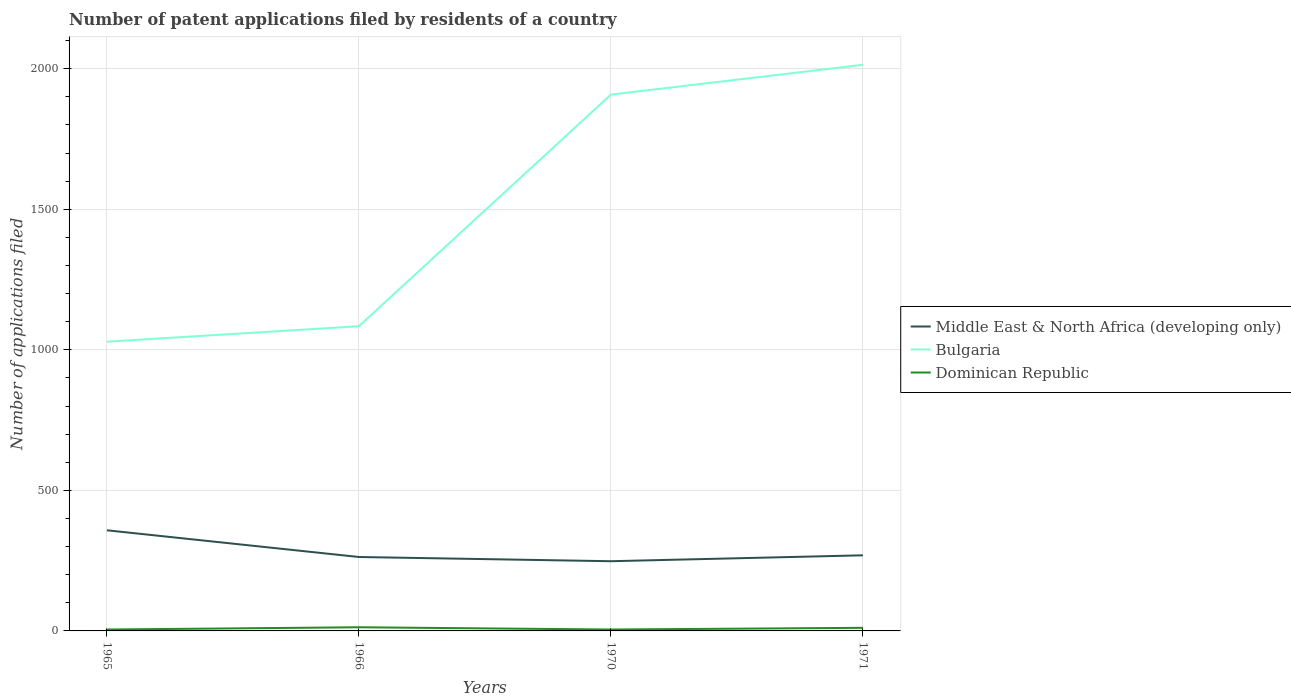Across all years, what is the maximum number of applications filed in Middle East & North Africa (developing only)?
Your answer should be very brief. 248. In which year was the number of applications filed in Middle East & North Africa (developing only) maximum?
Offer a very short reply. 1970. What is the total number of applications filed in Middle East & North Africa (developing only) in the graph?
Offer a terse response. 110. What is the difference between the highest and the second highest number of applications filed in Bulgaria?
Provide a succinct answer. 985. What is the difference between the highest and the lowest number of applications filed in Bulgaria?
Offer a very short reply. 2. How many years are there in the graph?
Your answer should be compact. 4. Does the graph contain grids?
Provide a short and direct response. Yes. Where does the legend appear in the graph?
Give a very brief answer. Center right. How are the legend labels stacked?
Your answer should be very brief. Vertical. What is the title of the graph?
Keep it short and to the point. Number of patent applications filed by residents of a country. Does "Honduras" appear as one of the legend labels in the graph?
Provide a succinct answer. No. What is the label or title of the X-axis?
Ensure brevity in your answer.  Years. What is the label or title of the Y-axis?
Your response must be concise. Number of applications filed. What is the Number of applications filed in Middle East & North Africa (developing only) in 1965?
Your response must be concise. 358. What is the Number of applications filed in Bulgaria in 1965?
Offer a very short reply. 1029. What is the Number of applications filed of Dominican Republic in 1965?
Give a very brief answer. 5. What is the Number of applications filed in Middle East & North Africa (developing only) in 1966?
Offer a terse response. 263. What is the Number of applications filed in Bulgaria in 1966?
Provide a succinct answer. 1084. What is the Number of applications filed of Dominican Republic in 1966?
Give a very brief answer. 13. What is the Number of applications filed in Middle East & North Africa (developing only) in 1970?
Your response must be concise. 248. What is the Number of applications filed of Bulgaria in 1970?
Give a very brief answer. 1908. What is the Number of applications filed in Dominican Republic in 1970?
Your answer should be compact. 5. What is the Number of applications filed of Middle East & North Africa (developing only) in 1971?
Give a very brief answer. 269. What is the Number of applications filed of Bulgaria in 1971?
Keep it short and to the point. 2014. What is the Number of applications filed of Dominican Republic in 1971?
Offer a very short reply. 11. Across all years, what is the maximum Number of applications filed in Middle East & North Africa (developing only)?
Keep it short and to the point. 358. Across all years, what is the maximum Number of applications filed in Bulgaria?
Make the answer very short. 2014. Across all years, what is the minimum Number of applications filed in Middle East & North Africa (developing only)?
Make the answer very short. 248. Across all years, what is the minimum Number of applications filed in Bulgaria?
Offer a very short reply. 1029. What is the total Number of applications filed of Middle East & North Africa (developing only) in the graph?
Offer a terse response. 1138. What is the total Number of applications filed of Bulgaria in the graph?
Provide a succinct answer. 6035. What is the difference between the Number of applications filed of Middle East & North Africa (developing only) in 1965 and that in 1966?
Keep it short and to the point. 95. What is the difference between the Number of applications filed in Bulgaria in 1965 and that in 1966?
Make the answer very short. -55. What is the difference between the Number of applications filed in Middle East & North Africa (developing only) in 1965 and that in 1970?
Offer a very short reply. 110. What is the difference between the Number of applications filed in Bulgaria in 1965 and that in 1970?
Give a very brief answer. -879. What is the difference between the Number of applications filed in Middle East & North Africa (developing only) in 1965 and that in 1971?
Your response must be concise. 89. What is the difference between the Number of applications filed in Bulgaria in 1965 and that in 1971?
Ensure brevity in your answer.  -985. What is the difference between the Number of applications filed of Middle East & North Africa (developing only) in 1966 and that in 1970?
Your answer should be very brief. 15. What is the difference between the Number of applications filed of Bulgaria in 1966 and that in 1970?
Offer a terse response. -824. What is the difference between the Number of applications filed in Dominican Republic in 1966 and that in 1970?
Provide a short and direct response. 8. What is the difference between the Number of applications filed in Middle East & North Africa (developing only) in 1966 and that in 1971?
Your response must be concise. -6. What is the difference between the Number of applications filed in Bulgaria in 1966 and that in 1971?
Provide a succinct answer. -930. What is the difference between the Number of applications filed in Middle East & North Africa (developing only) in 1970 and that in 1971?
Provide a succinct answer. -21. What is the difference between the Number of applications filed of Bulgaria in 1970 and that in 1971?
Your response must be concise. -106. What is the difference between the Number of applications filed in Middle East & North Africa (developing only) in 1965 and the Number of applications filed in Bulgaria in 1966?
Offer a terse response. -726. What is the difference between the Number of applications filed of Middle East & North Africa (developing only) in 1965 and the Number of applications filed of Dominican Republic in 1966?
Your answer should be compact. 345. What is the difference between the Number of applications filed of Bulgaria in 1965 and the Number of applications filed of Dominican Republic in 1966?
Give a very brief answer. 1016. What is the difference between the Number of applications filed in Middle East & North Africa (developing only) in 1965 and the Number of applications filed in Bulgaria in 1970?
Make the answer very short. -1550. What is the difference between the Number of applications filed of Middle East & North Africa (developing only) in 1965 and the Number of applications filed of Dominican Republic in 1970?
Make the answer very short. 353. What is the difference between the Number of applications filed in Bulgaria in 1965 and the Number of applications filed in Dominican Republic in 1970?
Offer a terse response. 1024. What is the difference between the Number of applications filed of Middle East & North Africa (developing only) in 1965 and the Number of applications filed of Bulgaria in 1971?
Provide a succinct answer. -1656. What is the difference between the Number of applications filed of Middle East & North Africa (developing only) in 1965 and the Number of applications filed of Dominican Republic in 1971?
Make the answer very short. 347. What is the difference between the Number of applications filed of Bulgaria in 1965 and the Number of applications filed of Dominican Republic in 1971?
Your answer should be compact. 1018. What is the difference between the Number of applications filed in Middle East & North Africa (developing only) in 1966 and the Number of applications filed in Bulgaria in 1970?
Provide a short and direct response. -1645. What is the difference between the Number of applications filed of Middle East & North Africa (developing only) in 1966 and the Number of applications filed of Dominican Republic in 1970?
Provide a short and direct response. 258. What is the difference between the Number of applications filed in Bulgaria in 1966 and the Number of applications filed in Dominican Republic in 1970?
Provide a short and direct response. 1079. What is the difference between the Number of applications filed in Middle East & North Africa (developing only) in 1966 and the Number of applications filed in Bulgaria in 1971?
Offer a terse response. -1751. What is the difference between the Number of applications filed of Middle East & North Africa (developing only) in 1966 and the Number of applications filed of Dominican Republic in 1971?
Offer a very short reply. 252. What is the difference between the Number of applications filed in Bulgaria in 1966 and the Number of applications filed in Dominican Republic in 1971?
Offer a terse response. 1073. What is the difference between the Number of applications filed of Middle East & North Africa (developing only) in 1970 and the Number of applications filed of Bulgaria in 1971?
Make the answer very short. -1766. What is the difference between the Number of applications filed in Middle East & North Africa (developing only) in 1970 and the Number of applications filed in Dominican Republic in 1971?
Provide a succinct answer. 237. What is the difference between the Number of applications filed of Bulgaria in 1970 and the Number of applications filed of Dominican Republic in 1971?
Ensure brevity in your answer.  1897. What is the average Number of applications filed of Middle East & North Africa (developing only) per year?
Offer a very short reply. 284.5. What is the average Number of applications filed of Bulgaria per year?
Make the answer very short. 1508.75. What is the average Number of applications filed of Dominican Republic per year?
Offer a terse response. 8.5. In the year 1965, what is the difference between the Number of applications filed in Middle East & North Africa (developing only) and Number of applications filed in Bulgaria?
Ensure brevity in your answer.  -671. In the year 1965, what is the difference between the Number of applications filed in Middle East & North Africa (developing only) and Number of applications filed in Dominican Republic?
Your answer should be very brief. 353. In the year 1965, what is the difference between the Number of applications filed of Bulgaria and Number of applications filed of Dominican Republic?
Keep it short and to the point. 1024. In the year 1966, what is the difference between the Number of applications filed in Middle East & North Africa (developing only) and Number of applications filed in Bulgaria?
Offer a very short reply. -821. In the year 1966, what is the difference between the Number of applications filed in Middle East & North Africa (developing only) and Number of applications filed in Dominican Republic?
Provide a short and direct response. 250. In the year 1966, what is the difference between the Number of applications filed of Bulgaria and Number of applications filed of Dominican Republic?
Your response must be concise. 1071. In the year 1970, what is the difference between the Number of applications filed of Middle East & North Africa (developing only) and Number of applications filed of Bulgaria?
Provide a short and direct response. -1660. In the year 1970, what is the difference between the Number of applications filed of Middle East & North Africa (developing only) and Number of applications filed of Dominican Republic?
Keep it short and to the point. 243. In the year 1970, what is the difference between the Number of applications filed of Bulgaria and Number of applications filed of Dominican Republic?
Make the answer very short. 1903. In the year 1971, what is the difference between the Number of applications filed of Middle East & North Africa (developing only) and Number of applications filed of Bulgaria?
Provide a succinct answer. -1745. In the year 1971, what is the difference between the Number of applications filed in Middle East & North Africa (developing only) and Number of applications filed in Dominican Republic?
Offer a very short reply. 258. In the year 1971, what is the difference between the Number of applications filed of Bulgaria and Number of applications filed of Dominican Republic?
Keep it short and to the point. 2003. What is the ratio of the Number of applications filed of Middle East & North Africa (developing only) in 1965 to that in 1966?
Give a very brief answer. 1.36. What is the ratio of the Number of applications filed of Bulgaria in 1965 to that in 1966?
Give a very brief answer. 0.95. What is the ratio of the Number of applications filed of Dominican Republic in 1965 to that in 1966?
Give a very brief answer. 0.38. What is the ratio of the Number of applications filed of Middle East & North Africa (developing only) in 1965 to that in 1970?
Keep it short and to the point. 1.44. What is the ratio of the Number of applications filed in Bulgaria in 1965 to that in 1970?
Give a very brief answer. 0.54. What is the ratio of the Number of applications filed of Dominican Republic in 1965 to that in 1970?
Make the answer very short. 1. What is the ratio of the Number of applications filed of Middle East & North Africa (developing only) in 1965 to that in 1971?
Your answer should be very brief. 1.33. What is the ratio of the Number of applications filed of Bulgaria in 1965 to that in 1971?
Ensure brevity in your answer.  0.51. What is the ratio of the Number of applications filed in Dominican Republic in 1965 to that in 1971?
Provide a succinct answer. 0.45. What is the ratio of the Number of applications filed of Middle East & North Africa (developing only) in 1966 to that in 1970?
Provide a short and direct response. 1.06. What is the ratio of the Number of applications filed in Bulgaria in 1966 to that in 1970?
Your answer should be compact. 0.57. What is the ratio of the Number of applications filed of Dominican Republic in 1966 to that in 1970?
Your response must be concise. 2.6. What is the ratio of the Number of applications filed of Middle East & North Africa (developing only) in 1966 to that in 1971?
Your answer should be compact. 0.98. What is the ratio of the Number of applications filed in Bulgaria in 1966 to that in 1971?
Ensure brevity in your answer.  0.54. What is the ratio of the Number of applications filed of Dominican Republic in 1966 to that in 1971?
Your response must be concise. 1.18. What is the ratio of the Number of applications filed of Middle East & North Africa (developing only) in 1970 to that in 1971?
Your response must be concise. 0.92. What is the ratio of the Number of applications filed of Dominican Republic in 1970 to that in 1971?
Offer a very short reply. 0.45. What is the difference between the highest and the second highest Number of applications filed of Middle East & North Africa (developing only)?
Your answer should be very brief. 89. What is the difference between the highest and the second highest Number of applications filed in Bulgaria?
Offer a very short reply. 106. What is the difference between the highest and the lowest Number of applications filed in Middle East & North Africa (developing only)?
Ensure brevity in your answer.  110. What is the difference between the highest and the lowest Number of applications filed in Bulgaria?
Your answer should be compact. 985. 